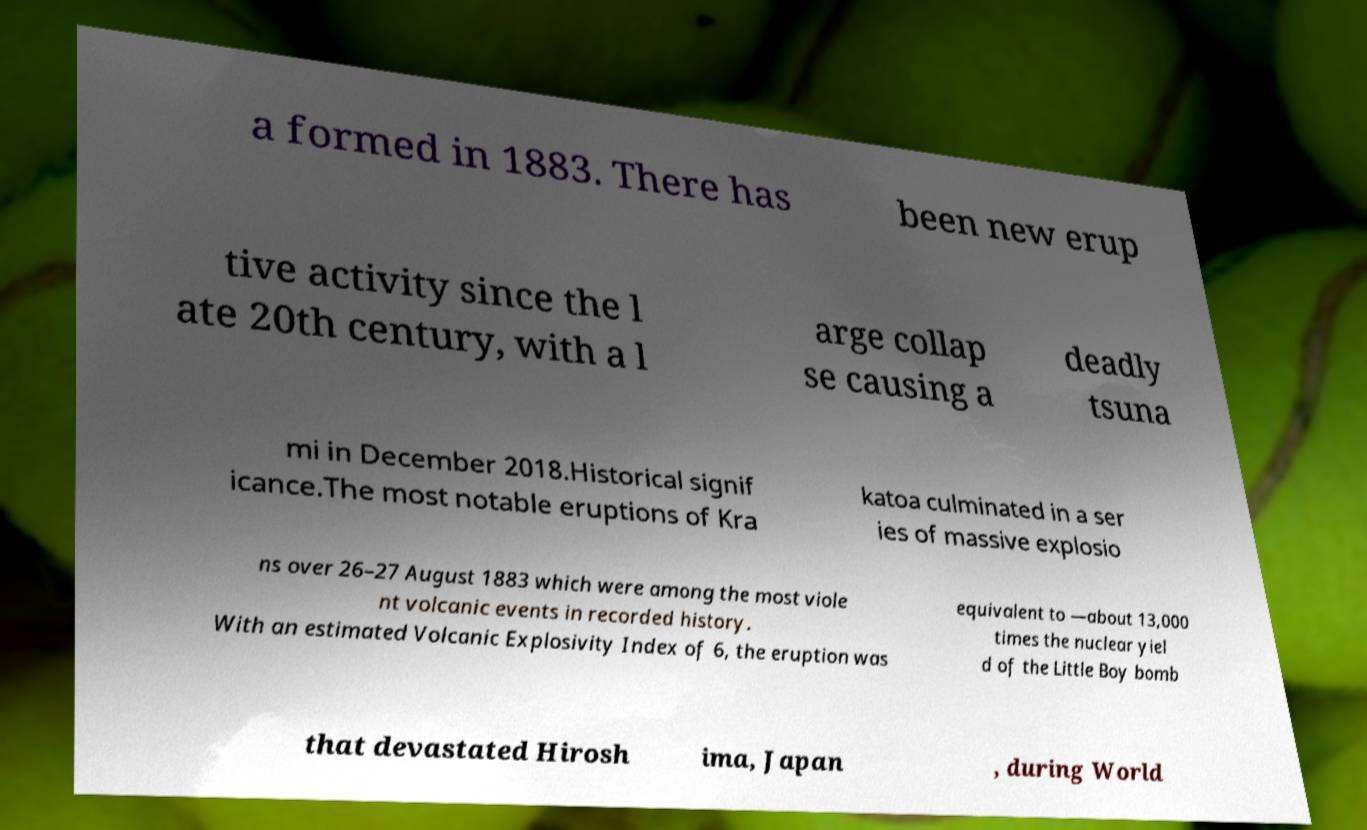Could you extract and type out the text from this image? a formed in 1883. There has been new erup tive activity since the l ate 20th century, with a l arge collap se causing a deadly tsuna mi in December 2018.Historical signif icance.The most notable eruptions of Kra katoa culminated in a ser ies of massive explosio ns over 26–27 August 1883 which were among the most viole nt volcanic events in recorded history. With an estimated Volcanic Explosivity Index of 6, the eruption was equivalent to —about 13,000 times the nuclear yiel d of the Little Boy bomb that devastated Hirosh ima, Japan , during World 